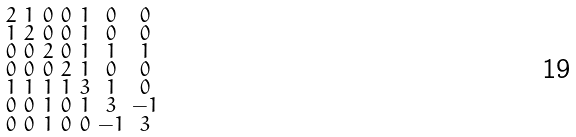Convert formula to latex. <formula><loc_0><loc_0><loc_500><loc_500>\begin{smallmatrix} 2 & 1 & 0 & 0 & 1 & 0 & 0 \\ 1 & 2 & 0 & 0 & 1 & 0 & 0 \\ 0 & 0 & 2 & 0 & 1 & 1 & 1 \\ 0 & 0 & 0 & 2 & 1 & 0 & 0 \\ 1 & 1 & 1 & 1 & 3 & 1 & 0 \\ 0 & 0 & 1 & 0 & 1 & 3 & - 1 \\ 0 & 0 & 1 & 0 & 0 & - 1 & 3 \end{smallmatrix}</formula> 